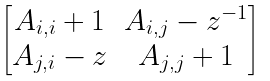Convert formula to latex. <formula><loc_0><loc_0><loc_500><loc_500>\begin{bmatrix} A _ { i , i } + 1 & A _ { i , j } - z ^ { - 1 } \\ A _ { j , i } - z & A _ { j , j } + 1 \end{bmatrix}</formula> 